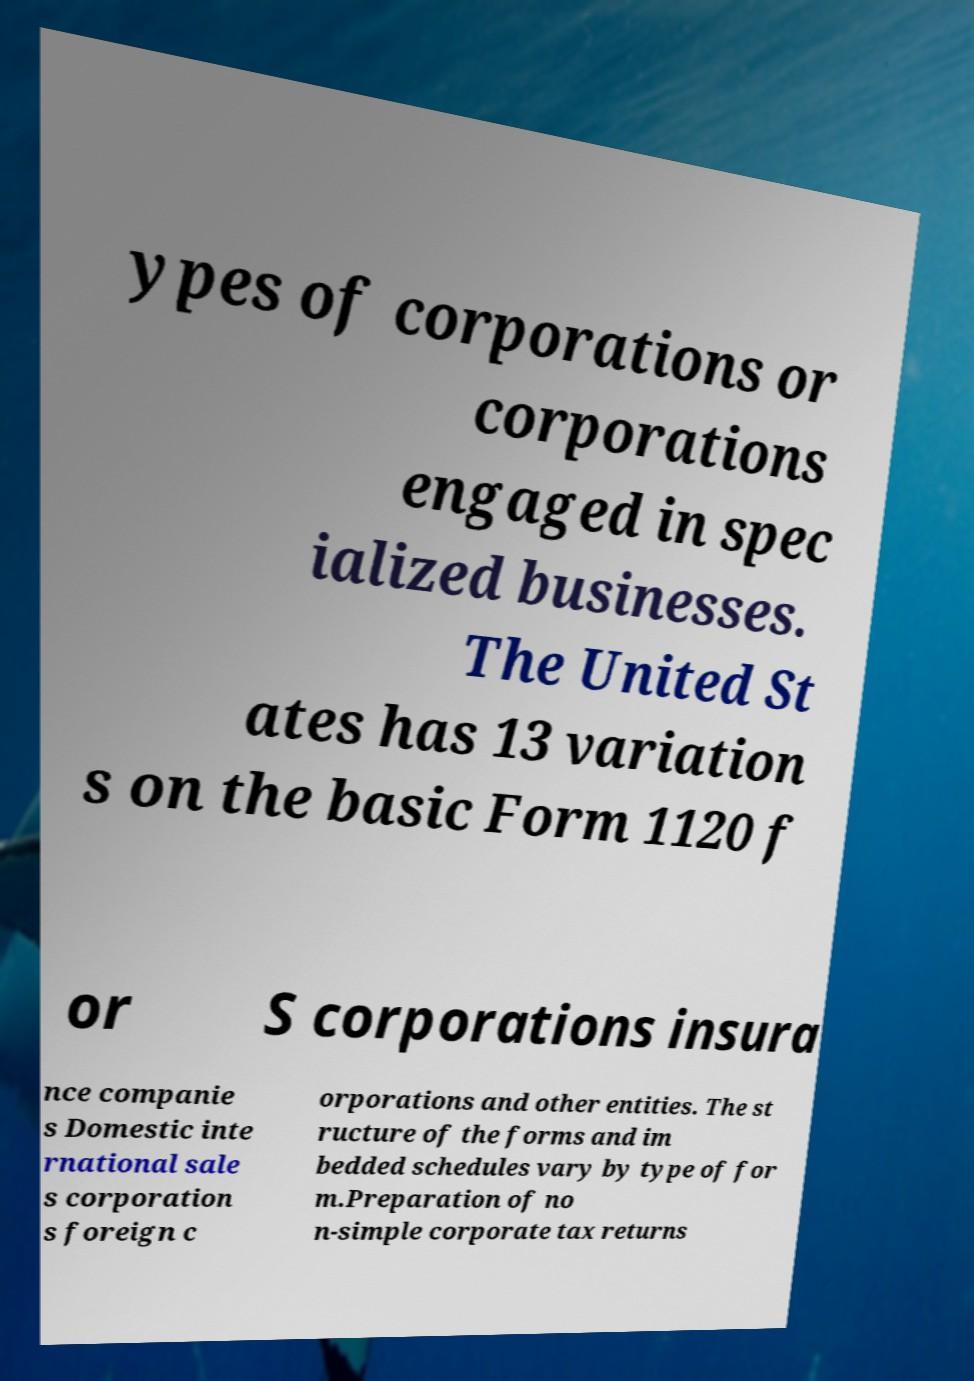What messages or text are displayed in this image? I need them in a readable, typed format. ypes of corporations or corporations engaged in spec ialized businesses. The United St ates has 13 variation s on the basic Form 1120 f or S corporations insura nce companie s Domestic inte rnational sale s corporation s foreign c orporations and other entities. The st ructure of the forms and im bedded schedules vary by type of for m.Preparation of no n-simple corporate tax returns 